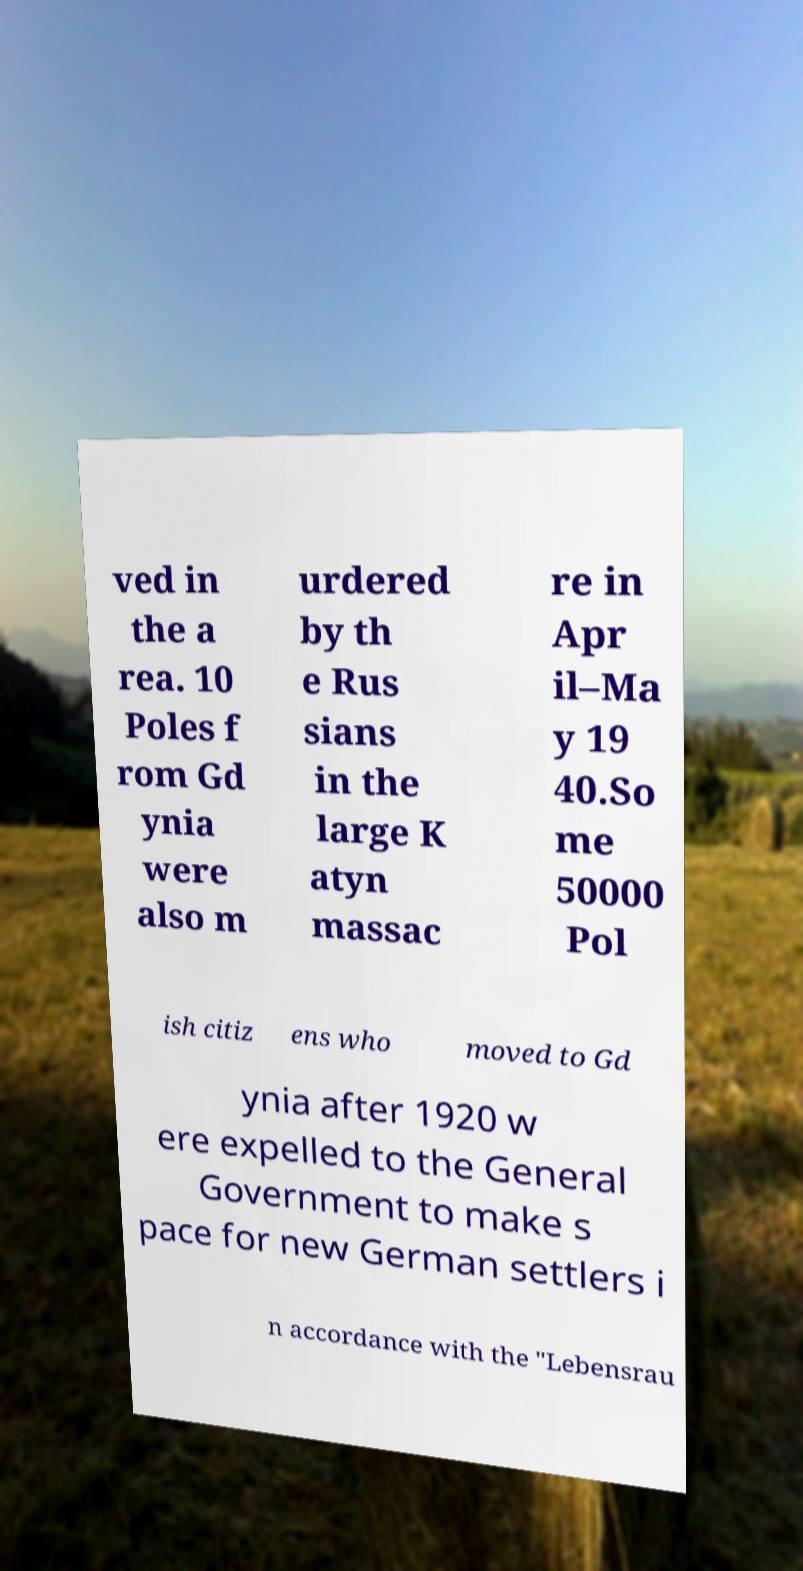Please read and relay the text visible in this image. What does it say? ved in the a rea. 10 Poles f rom Gd ynia were also m urdered by th e Rus sians in the large K atyn massac re in Apr il–Ma y 19 40.So me 50000 Pol ish citiz ens who moved to Gd ynia after 1920 w ere expelled to the General Government to make s pace for new German settlers i n accordance with the "Lebensrau 